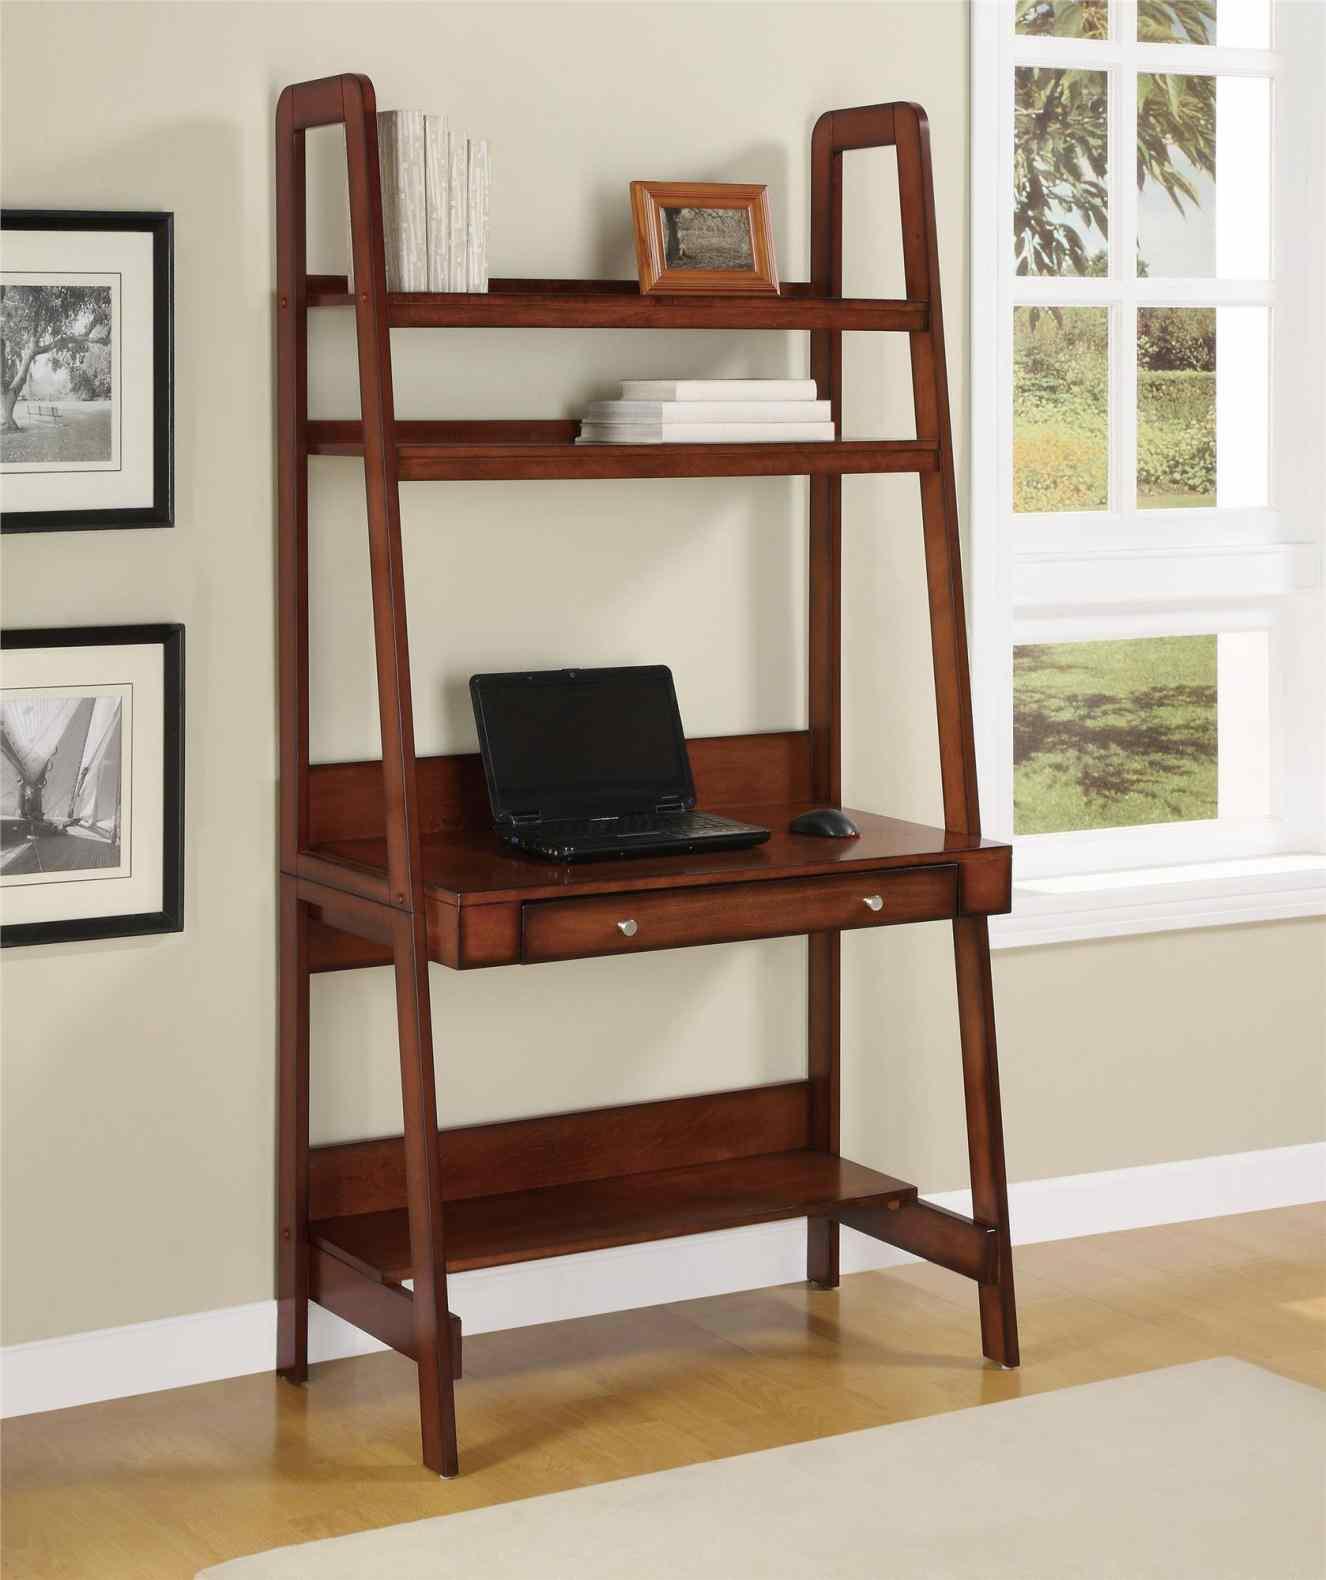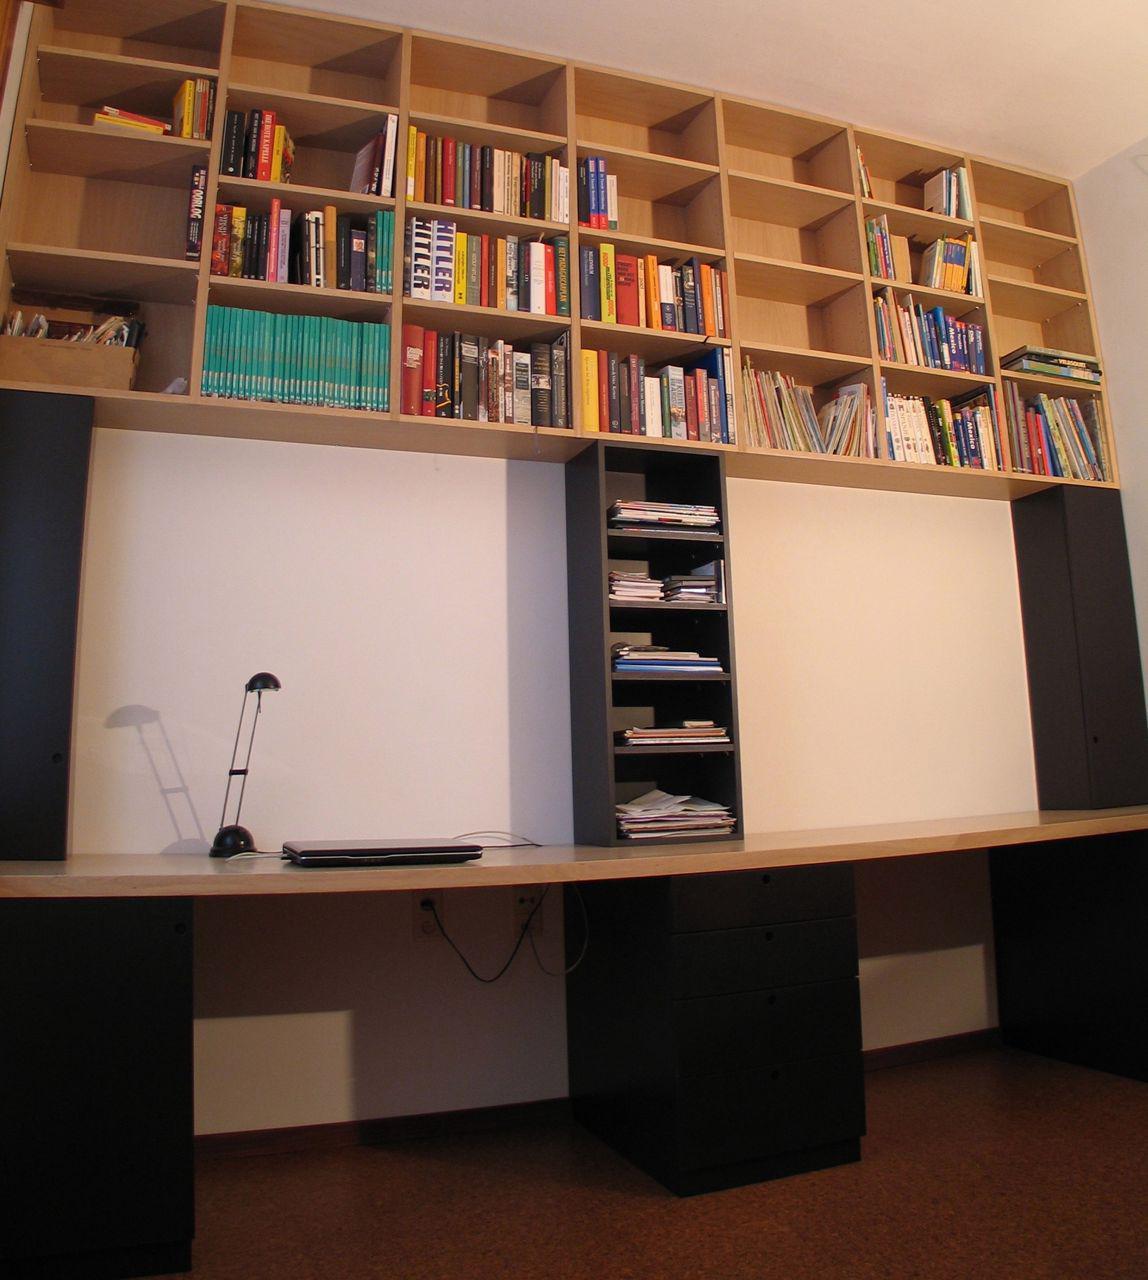The first image is the image on the left, the second image is the image on the right. Examine the images to the left and right. Is the description "A combination desk and shelf unit is built at an angle to a wall, becoming wider as it gets closer to the floor, with a small desk area in the center." accurate? Answer yes or no. Yes. The first image is the image on the left, the second image is the image on the right. Given the left and right images, does the statement "One image features an open-backed shelf with a front that angles toward a white wall like a ladder." hold true? Answer yes or no. Yes. 